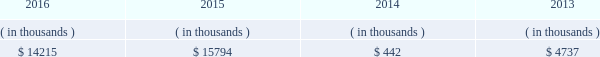Entergy new orleans , inc .
And subsidiaries management 2019s financial discussion and analysis entergy new orleans 2019s receivables from the money pool were as follows as of december 31 for each of the following years. .
See note 4 to the financial statements for a description of the money pool .
Entergy new orleans has a credit facility in the amount of $ 25 million scheduled to expire in november 2018 .
The credit facility allows entergy new orleans to issue letters of credit against $ 10 million of the borrowing capacity of the facility .
As of december 31 , 2016 , there were no cash borrowings and a $ 0.8 million letter of credit was outstanding under the facility .
In addition , entergy new orleans is a party to an uncommitted letter of credit facility as a means to post collateral to support its obligations under miso .
As of december 31 , 2016 , a $ 6.2 million letter of credit was outstanding under entergy new orleans 2019s letter of credit facility .
See note 4 to the financial statements for additional discussion of the credit facilities .
Entergy new orleans obtained authorization from the ferc through october 2017 for short-term borrowings not to exceed an aggregate amount of $ 100 million at any time outstanding .
See note 4 to the financial statements for further discussion of entergy new orleans 2019s short-term borrowing limits .
The long-term securities issuances of entergy new orleans are limited to amounts authorized by the city council , and the current authorization extends through june 2018 .
State and local rate regulation the rates that entergy new orleans charges for electricity and natural gas significantly influence its financial position , results of operations , and liquidity .
Entergy new orleans is regulated and the rates charged to its customers are determined in regulatory proceedings .
A governmental agency , the city council , is primarily responsible for approval of the rates charged to customers .
Retail rates see 201calgiers asset transfer 201d below for discussion of the transfer from entergy louisiana to entergy new orleans of certain assets that serve algiers customers .
In march 2013 , entergy louisiana filed a rate case for the algiers area , which is in new orleans and is regulated by the city council .
Entergy louisiana requested a rate increase of $ 13 million over three years , including a 10.4% ( 10.4 % ) return on common equity and a formula rate plan mechanism identical to its lpsc request .
In january 2014 the city council advisors filed direct testimony recommending a rate increase of $ 5.56 million over three years , including an 8.13% ( 8.13 % ) return on common equity .
In june 2014 the city council unanimously approved a settlement that includes the following : 2022 a $ 9.3 million base rate revenue increase to be phased in on a levelized basis over four years ; 2022 recovery of an additional $ 853 thousand annually through a miso recovery rider ; and 2022 the adoption of a four-year formula rate plan requiring the filing of annual evaluation reports in may of each year , commencing may 2015 , with resulting rates being implemented in october of each year .
The formula rate plan includes a midpoint target authorized return on common equity of 9.95% ( 9.95 % ) with a +/- 40 basis point bandwidth .
The rate increase was effective with bills rendered on and after the first billing cycle of july 2014 .
Additional compliance filings were made with the city council in october 2014 for approval of the form of certain rate riders , including among others , a ninemile 6 non-fuel cost recovery interim rider , allowing for contemporaneous recovery of capacity .
What was the combined amount of receivables for 2013 through 2016 ( in thousands ) from the money pool? 
Computations: (((14215 + 15794) + 442) + 4737)
Answer: 35188.0. 